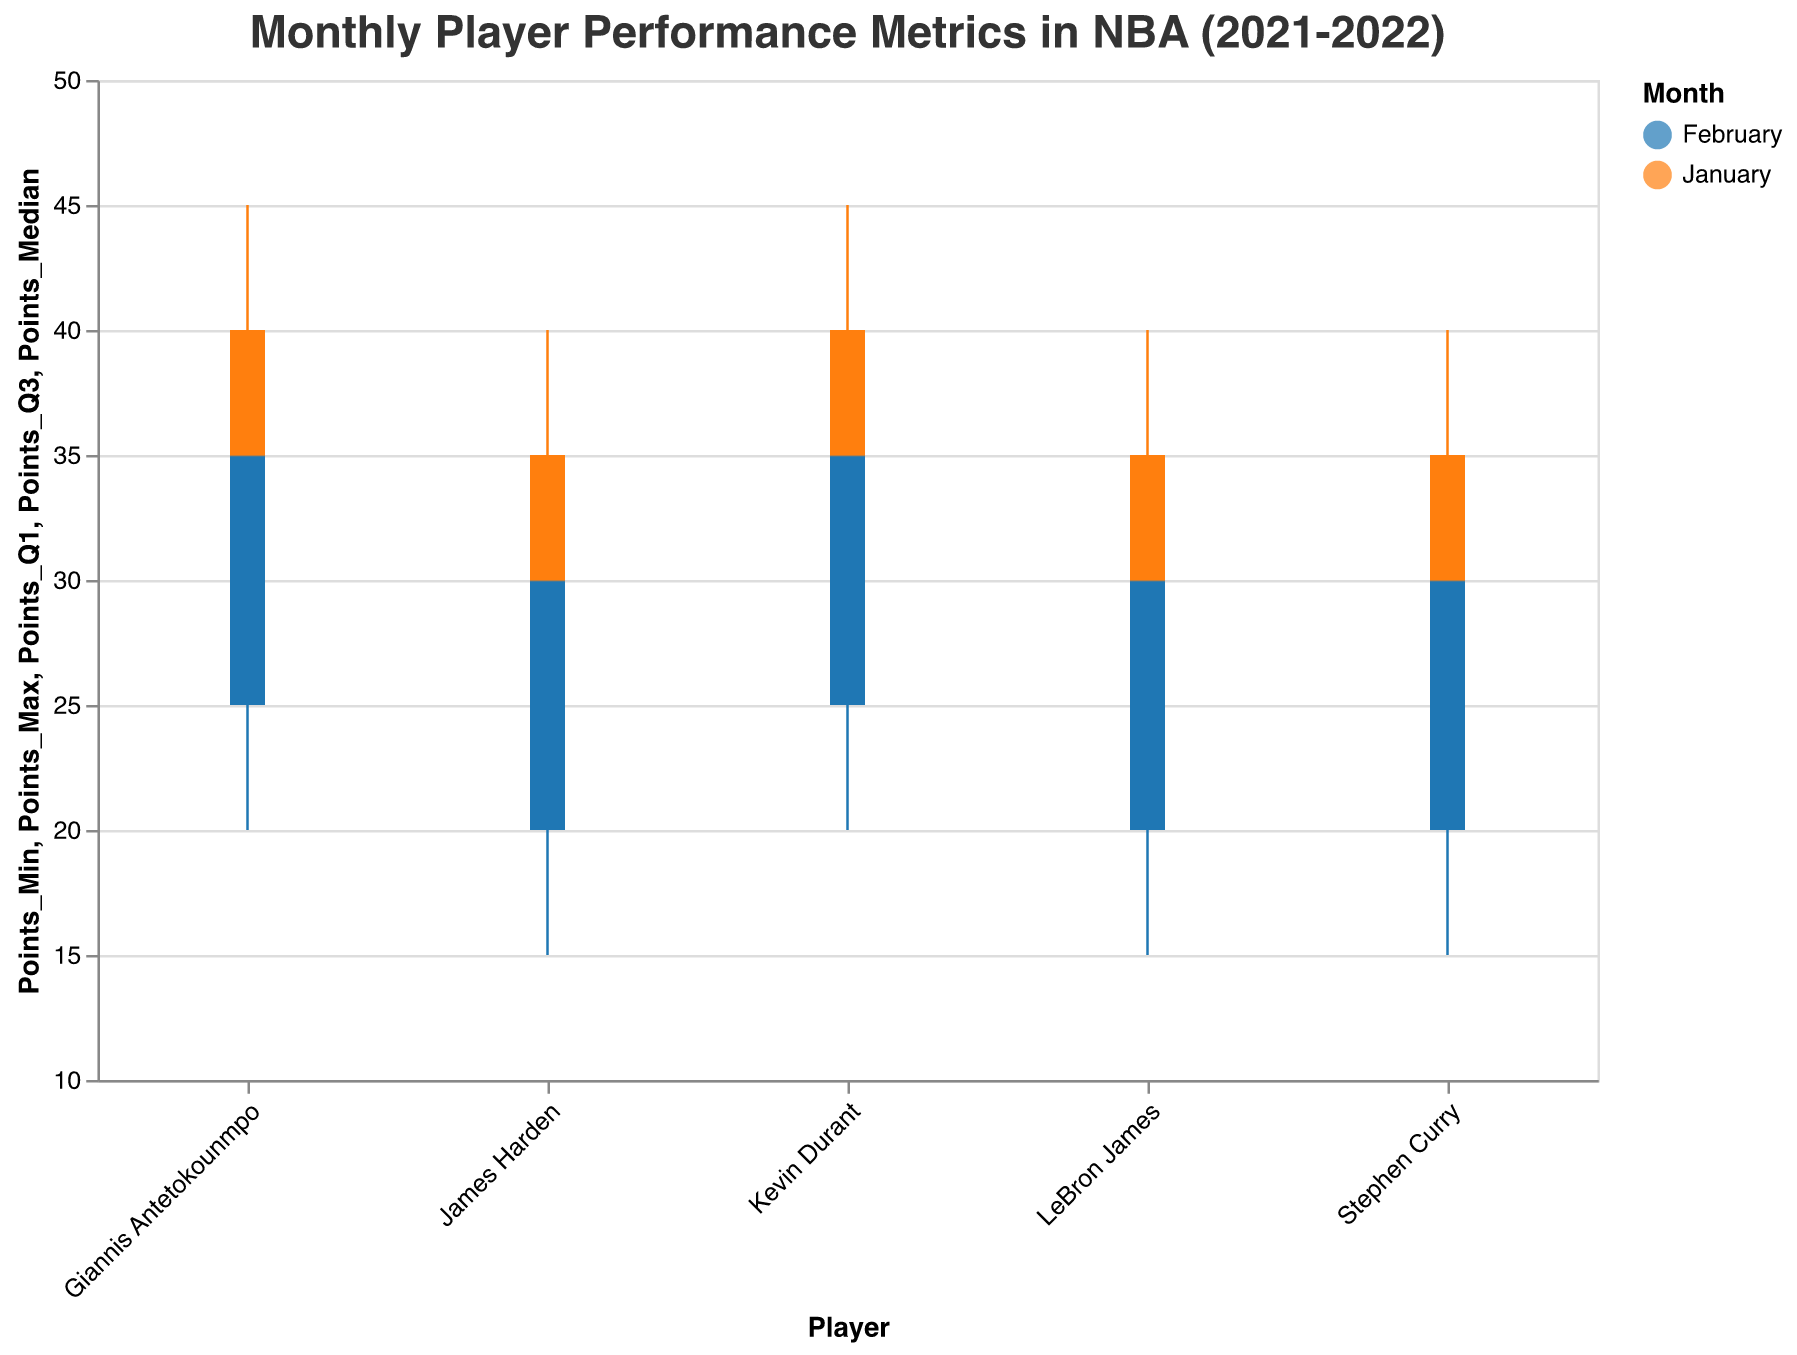Which month shows the highest median points for Kevin Durant? To find this, look at the median points for Kevin Durant in each month. January shows a median of 35, while February shows a median of 30. Therefore, January has the highest median points.
Answer: January What is the median number of assists for Stephen Curry in January? Examine Stephen Curry's median assists in January. The figure shows the median value where the tick mark intersects the wider bar, labeled as January for Stephen Curry, which shows a value of 8.
Answer: 8 Which player had the lowest minimum point score in February? For this, compare the minimum points for each player in February. LeBron James, Stephen Curry, and James Harden all have a minimum score of 15, but among them, the lowest value is uniformly shared.
Answer: LeBron James, Stephen Curry, James Harden How do LeBron James' assists compare between January and February? Look at the quartiles for assists for LeBron James in both months. The median assist in January is 7, whereas in February it is 6. Similarly, all other quartiles indicate a drop from January to February.
Answer: Higher in January What's the range of rebounds for Giannis Antetokounmpo in January? To find the range, subtract the minimum value of rebounds from the maximum value in January for Giannis Antetokounmpo. For January, the maximum is 11 and the minimum is 7. The range is 11 - 7.
Answer: 4 Who had the least variability in points in January? Points variability is represented by the distance between the minimum and maximum points. Kevin Durant and Giannis Antetokounmpo both have a range of 20 (45 - 25), while James Harden, Stephen Curry, and LeBron James have the same range of 20 (40 - 20). So, all have equal variability.
Answer: All players have equal variability Which player has the highest median points in January? Identify the tick marks representing the median points for all players in January. Kevin Durant and Giannis Antetokounmpo both show a median of 35, the highest among all players.
Answer: Kevin Durant, Giannis Antetokounmpo Calculate the average of the median points for all players in February. Identify the median points for all players in February, which are LeBron James (25), Kevin Durant (30), Stephen Curry (25), Giannis Antetokounmpo (30), and James Harden (25). Calculate the average by summing these values and dividing by the number of players: (25 + 30 + 25 + 30 + 25) / 5 = 27.
Answer: 27 Who had the highest maximum assists in January? Look at the maximum assists for all players in January. James Harden has a maximum of 11, higher than any other player.
Answer: James Harden 